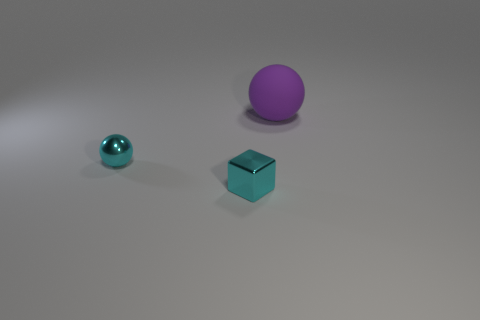What is the color of the thing that is behind the metal block and to the left of the big purple sphere?
Your answer should be very brief. Cyan. Are there any other things that are the same size as the purple sphere?
Offer a very short reply. No. Is the number of small blue matte cubes greater than the number of small cyan balls?
Provide a short and direct response. No. How big is the object that is right of the cyan ball and left of the large thing?
Give a very brief answer. Small. How many tiny blue things are the same shape as the purple matte object?
Provide a succinct answer. 0. Are there fewer cyan metal cubes that are in front of the cube than cyan metallic things that are to the right of the cyan sphere?
Ensure brevity in your answer.  Yes. How many cyan metal blocks are right of the ball that is in front of the purple rubber thing?
Provide a short and direct response. 1. Are there any big cyan metallic objects?
Your answer should be very brief. No. Is there a tiny cyan block made of the same material as the cyan sphere?
Offer a very short reply. Yes. Are there more things that are in front of the purple rubber ball than big purple spheres that are to the left of the small metallic sphere?
Keep it short and to the point. Yes. 